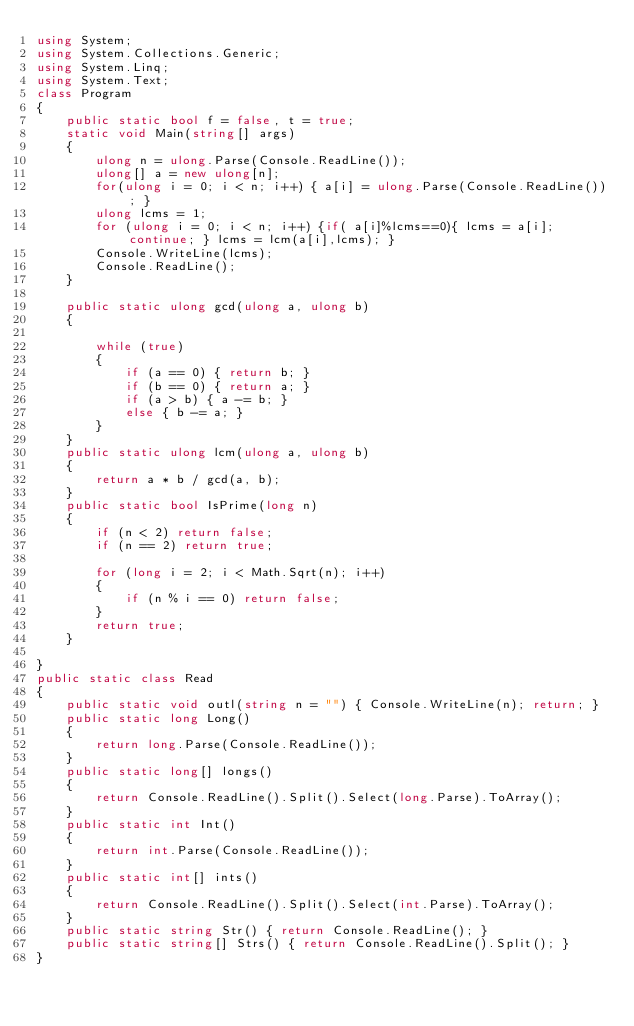<code> <loc_0><loc_0><loc_500><loc_500><_C#_>using System;
using System.Collections.Generic;
using System.Linq;
using System.Text;
class Program
{
    public static bool f = false, t = true;
    static void Main(string[] args)
    {
        ulong n = ulong.Parse(Console.ReadLine());
        ulong[] a = new ulong[n];
        for(ulong i = 0; i < n; i++) { a[i] = ulong.Parse(Console.ReadLine()); }
        ulong lcms = 1;
        for (ulong i = 0; i < n; i++) {if( a[i]%lcms==0){ lcms = a[i]; continue; } lcms = lcm(a[i],lcms); }
        Console.WriteLine(lcms);
        Console.ReadLine();
    }

    public static ulong gcd(ulong a, ulong b)
    {

        while (true)
        {
            if (a == 0) { return b; }
            if (b == 0) { return a; }
            if (a > b) { a -= b; }
            else { b -= a; }
        }
    }
    public static ulong lcm(ulong a, ulong b)
    {
        return a * b / gcd(a, b);
    }
    public static bool IsPrime(long n)
    {
        if (n < 2) return false;
        if (n == 2) return true;

        for (long i = 2; i < Math.Sqrt(n); i++)
        {
            if (n % i == 0) return false;
        }
        return true;
    }

}
public static class Read
{
    public static void outl(string n = "") { Console.WriteLine(n); return; }
    public static long Long()
    {
        return long.Parse(Console.ReadLine());
    }
    public static long[] longs()
    {
        return Console.ReadLine().Split().Select(long.Parse).ToArray();
    }
    public static int Int()
    {
        return int.Parse(Console.ReadLine());
    }
    public static int[] ints()
    {
        return Console.ReadLine().Split().Select(int.Parse).ToArray();
    }
    public static string Str() { return Console.ReadLine(); }
    public static string[] Strs() { return Console.ReadLine().Split(); }
}</code> 